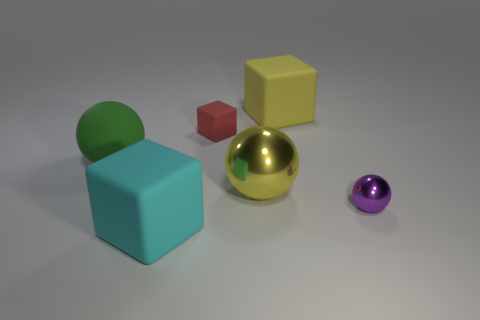What number of rubber things are either purple cylinders or purple balls?
Offer a very short reply. 0. What number of green rubber things are there?
Make the answer very short. 1. Is the material of the tiny object that is behind the tiny purple thing the same as the ball that is to the right of the yellow cube?
Provide a short and direct response. No. There is another shiny thing that is the same shape as the purple object; what is its color?
Offer a terse response. Yellow. What material is the small thing that is to the left of the large cube that is right of the cyan matte thing?
Offer a terse response. Rubber. There is a big matte thing that is right of the large shiny object; is its shape the same as the big yellow thing that is in front of the big green matte sphere?
Give a very brief answer. No. What size is the block that is both behind the tiny purple thing and to the left of the yellow sphere?
Give a very brief answer. Small. How many other things are the same color as the tiny shiny thing?
Your answer should be very brief. 0. Is the big ball that is in front of the large rubber ball made of the same material as the large cyan block?
Give a very brief answer. No. Is the number of yellow objects in front of the purple object less than the number of objects to the right of the yellow matte thing?
Your response must be concise. Yes. 